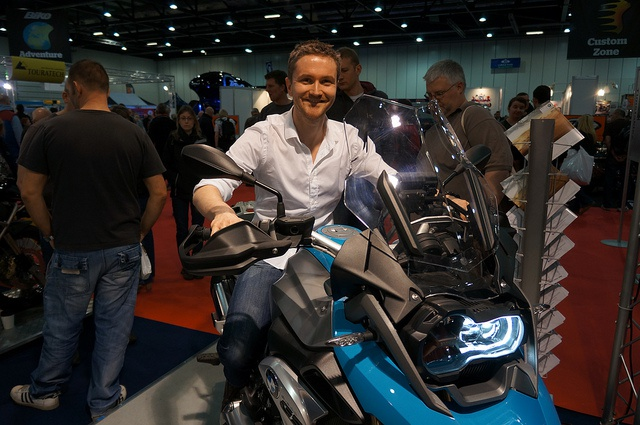Describe the objects in this image and their specific colors. I can see motorcycle in black, gray, teal, and blue tones, people in black, maroon, and gray tones, people in black, lightgray, gray, and darkgray tones, people in black, maroon, and gray tones, and motorcycle in black and gray tones in this image. 